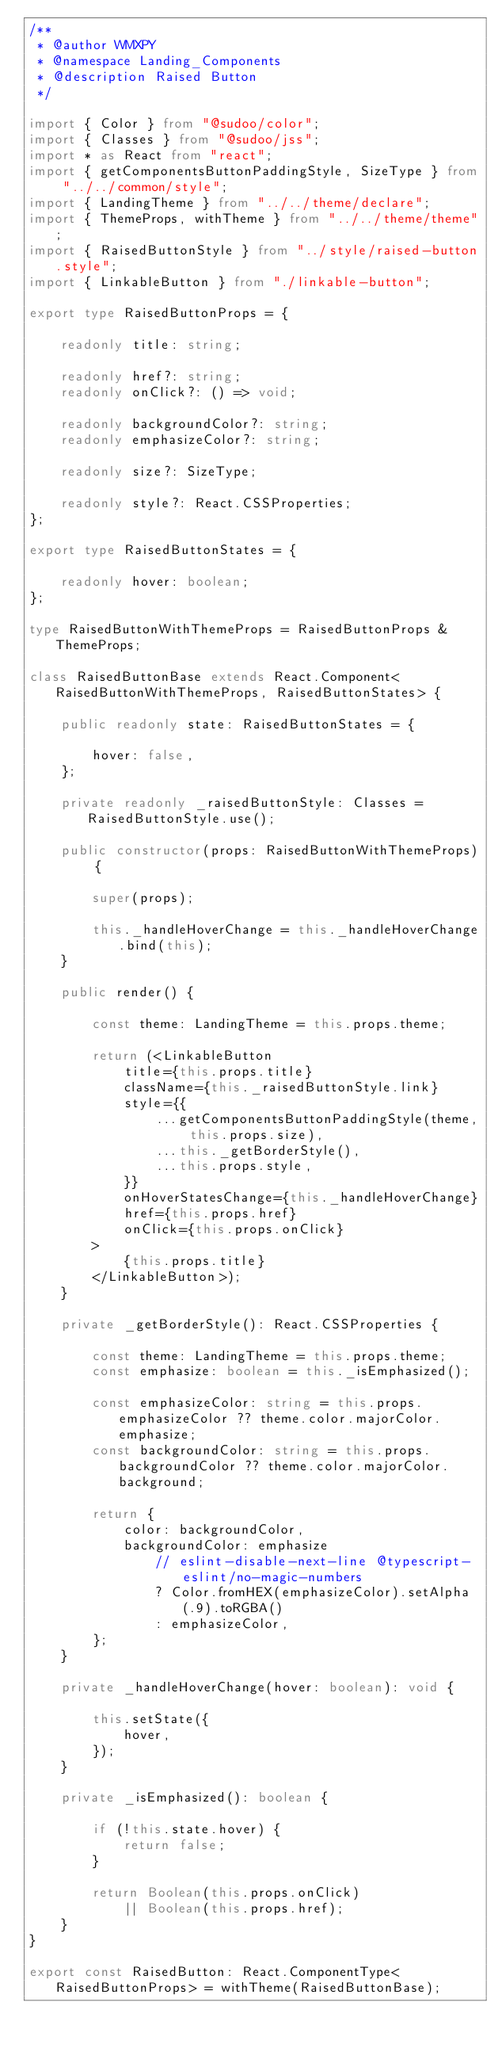Convert code to text. <code><loc_0><loc_0><loc_500><loc_500><_TypeScript_>/**
 * @author WMXPY
 * @namespace Landing_Components
 * @description Raised Button
 */

import { Color } from "@sudoo/color";
import { Classes } from "@sudoo/jss";
import * as React from "react";
import { getComponentsButtonPaddingStyle, SizeType } from "../../common/style";
import { LandingTheme } from "../../theme/declare";
import { ThemeProps, withTheme } from "../../theme/theme";
import { RaisedButtonStyle } from "../style/raised-button.style";
import { LinkableButton } from "./linkable-button";

export type RaisedButtonProps = {

    readonly title: string;

    readonly href?: string;
    readonly onClick?: () => void;

    readonly backgroundColor?: string;
    readonly emphasizeColor?: string;

    readonly size?: SizeType;

    readonly style?: React.CSSProperties;
};

export type RaisedButtonStates = {

    readonly hover: boolean;
};

type RaisedButtonWithThemeProps = RaisedButtonProps & ThemeProps;

class RaisedButtonBase extends React.Component<RaisedButtonWithThemeProps, RaisedButtonStates> {

    public readonly state: RaisedButtonStates = {

        hover: false,
    };

    private readonly _raisedButtonStyle: Classes = RaisedButtonStyle.use();

    public constructor(props: RaisedButtonWithThemeProps) {

        super(props);

        this._handleHoverChange = this._handleHoverChange.bind(this);
    }

    public render() {

        const theme: LandingTheme = this.props.theme;

        return (<LinkableButton
            title={this.props.title}
            className={this._raisedButtonStyle.link}
            style={{
                ...getComponentsButtonPaddingStyle(theme, this.props.size),
                ...this._getBorderStyle(),
                ...this.props.style,
            }}
            onHoverStatesChange={this._handleHoverChange}
            href={this.props.href}
            onClick={this.props.onClick}
        >
            {this.props.title}
        </LinkableButton>);
    }

    private _getBorderStyle(): React.CSSProperties {

        const theme: LandingTheme = this.props.theme;
        const emphasize: boolean = this._isEmphasized();

        const emphasizeColor: string = this.props.emphasizeColor ?? theme.color.majorColor.emphasize;
        const backgroundColor: string = this.props.backgroundColor ?? theme.color.majorColor.background;

        return {
            color: backgroundColor,
            backgroundColor: emphasize
                // eslint-disable-next-line @typescript-eslint/no-magic-numbers
                ? Color.fromHEX(emphasizeColor).setAlpha(.9).toRGBA()
                : emphasizeColor,
        };
    }

    private _handleHoverChange(hover: boolean): void {

        this.setState({
            hover,
        });
    }

    private _isEmphasized(): boolean {

        if (!this.state.hover) {
            return false;
        }

        return Boolean(this.props.onClick)
            || Boolean(this.props.href);
    }
}

export const RaisedButton: React.ComponentType<RaisedButtonProps> = withTheme(RaisedButtonBase);
</code> 